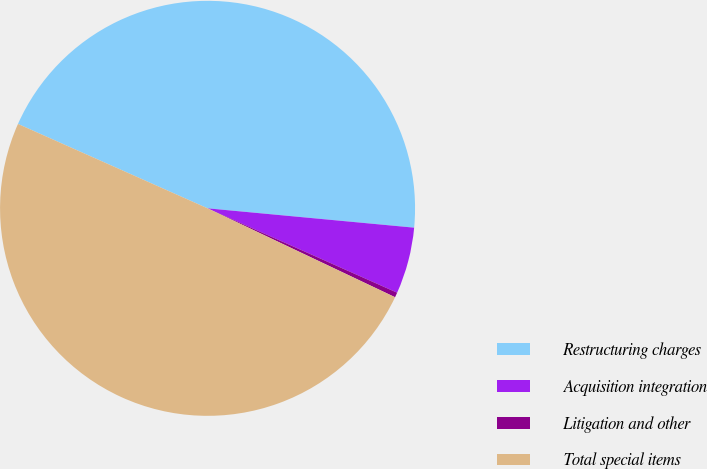Convert chart to OTSL. <chart><loc_0><loc_0><loc_500><loc_500><pie_chart><fcel>Restructuring charges<fcel>Acquisition integration<fcel>Litigation and other<fcel>Total special items<nl><fcel>44.82%<fcel>5.18%<fcel>0.38%<fcel>49.62%<nl></chart> 